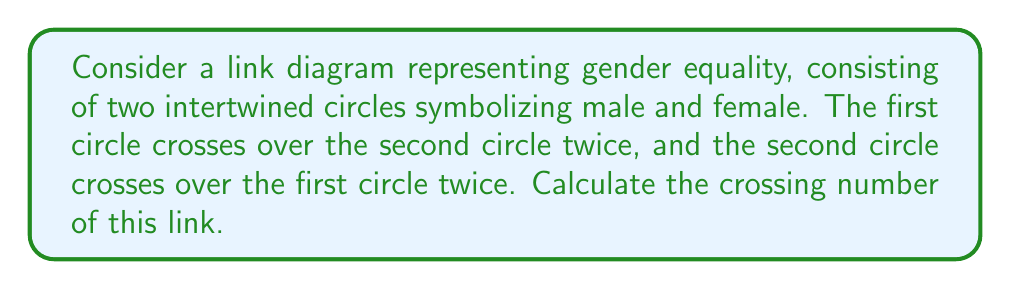What is the answer to this math problem? To calculate the crossing number of this link, we need to follow these steps:

1. Understand the link diagram:
   - We have two circles (components) intertwined.
   - Each circle crosses over the other twice.

2. Count the crossings:
   - The first circle crosses over the second circle twice: 2 crossings
   - The second circle crosses over the first circle twice: 2 crossings
   - Total number of crossings: $2 + 2 = 4$

3. Verify if this is the minimal crossing number:
   - In this case, the given diagram is already in its simplest form.
   - No crossing can be eliminated without changing the link type.

4. The crossing number is defined as the minimum number of crossings over all possible diagrams of the link.
   - Since our diagram is in its simplest form, the crossing number equals the number of crossings we counted.

Therefore, the crossing number of this link symbolizing gender equality is 4.

[asy]
unitsize(1cm);

path c1 = circle((0,0),1);
path c2 = circle((0.5,0),1);

draw(c1,blue);
draw(c2,red);

draw((-0.3,-0.95)--(-0.3,0.95),blue);
draw((0.8,-0.95)--(0.8,0.95),red);

dot((0.25,-0.7));
dot((0.25,0.7));
dot((-0.05,-0.7));
dot((-0.05,0.7));

label("1", (0.25,-0.9), S);
label("2", (0.25,0.9), N);
label("3", (-0.05,-0.9), S);
label("4", (-0.05,0.9), N);
[/asy]
Answer: 4 